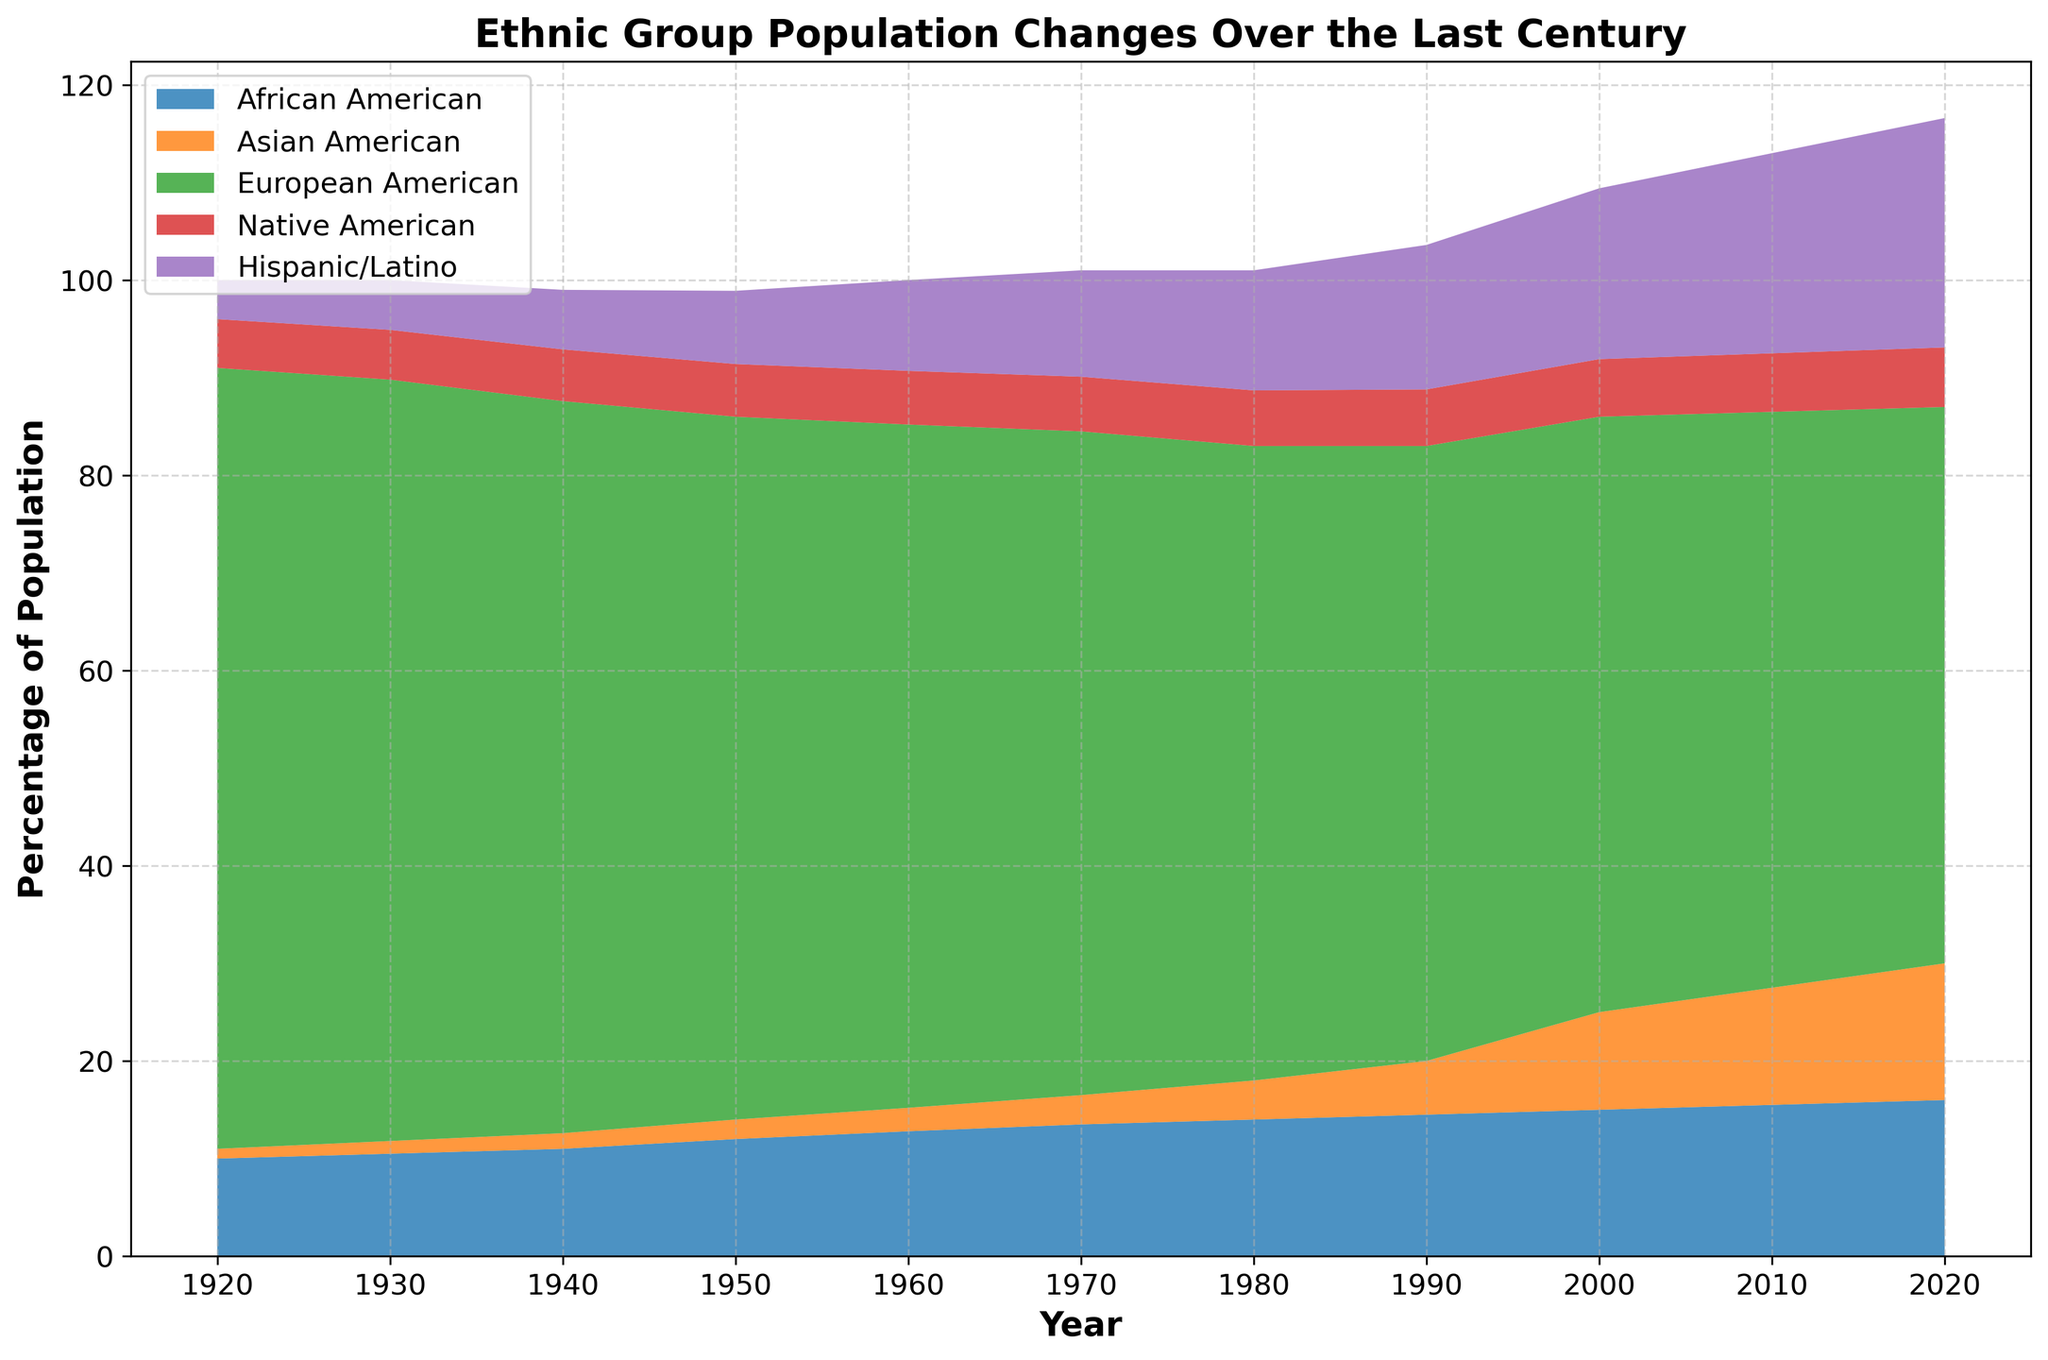What is the percentage of Asian Americans in 1920? To find the percentage of Asian Americans in 1920, look at the data point or color segment corresponding to that year. It shows Asian Americans accounted for 1% of the population.
Answer: 1% What is the difference in the percentage of African Americans between 1920 and 2020? Locate the heights of the African American portion of the area chart for 1920 and 2020. In 1920, it was 10%, and in 2020, it was 16%. Subtract the 1920 value from the 2020 value: 16% - 10% = 6%.
Answer: 6% Which ethnic group showed the highest percentage increase from 1920 to 2020? Examine the peaks of each color segment representing different ethnic groups and compare the height differences from 1920 to 2020. The Hispanic/Latino group grew from 4% to 23.5%, showing the highest increase of 19.5%.
Answer: Hispanic/Latino What is the sum of Native American and Hispanic/Latino populations in 1950? Look at the data points for Native Americans and Hispanic/Latinos in 1950. Native Americans were at 5.4% and Hispanic/Latinos at 7.5%. Add these values: 5.4% + 7.5% = 12.9%.
Answer: 12.9% Among Native Americans and European Americans, which group had a higher percentage in 1940? Compare the heights of the respective segments for Native Americans and European Americans in 1940. Native Americans had 5.3%, and European Americans had 75%. Hence, European Americans had a higher percentage.
Answer: European Americans What was the percentage of the Asian American population relative to the African American population in 2010? Determine the percentages of Asian Americans and African Americans in 2010: 12% and 15.5% respectively. Calculate the ratio as (12 / 15.5) * 100% ≈ 77.4%.
Answer: 77.4% In which decade did the African American population reach 13% for the first time? Look at the trend for the African American segment and identify when it first crossed 13%. This happened around 1960.
Answer: 1960 What is the average percentage of the Hispanic/Latino population across all the given years? Calculate the average by summing the percentages from 1920 to 2020 and dividing by the number of decades: (4 + 5.1 + 6.1 + 7.5 + 9.3 + 10.9 + 12.3 + 14.8 + 17.5 + 20.5 + 23.5) / 11 ≈ 12.6%.
Answer: 12.6% What decade showed the steepest increase for the Asian American population? Observe the Asian American segment and find the steepest upward slope between decades. They experienced the highest increase between 1980 and 1990, from 4% to 5.5%.
Answer: 1980-1990 What is the combined percentage of African Americans and European Americans in 1920? Locate the data for African Americans and European Americans in 1920, add their percentages: 10% + 80% = 90%.
Answer: 90% 